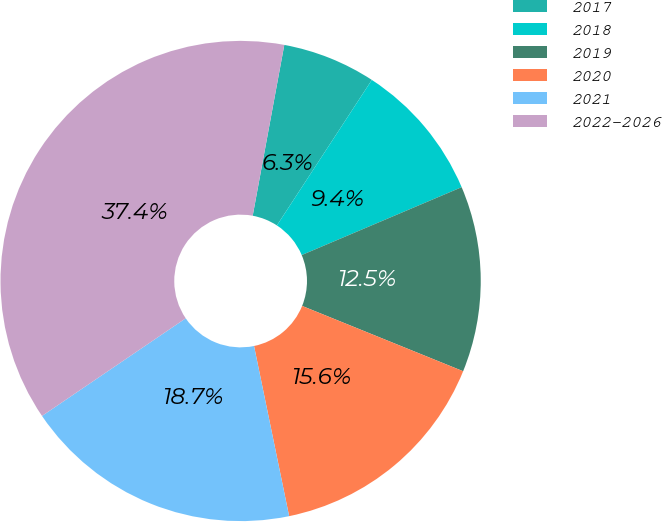Convert chart. <chart><loc_0><loc_0><loc_500><loc_500><pie_chart><fcel>2017<fcel>2018<fcel>2019<fcel>2020<fcel>2021<fcel>2022-2026<nl><fcel>6.29%<fcel>9.41%<fcel>12.52%<fcel>15.63%<fcel>18.74%<fcel>37.41%<nl></chart> 